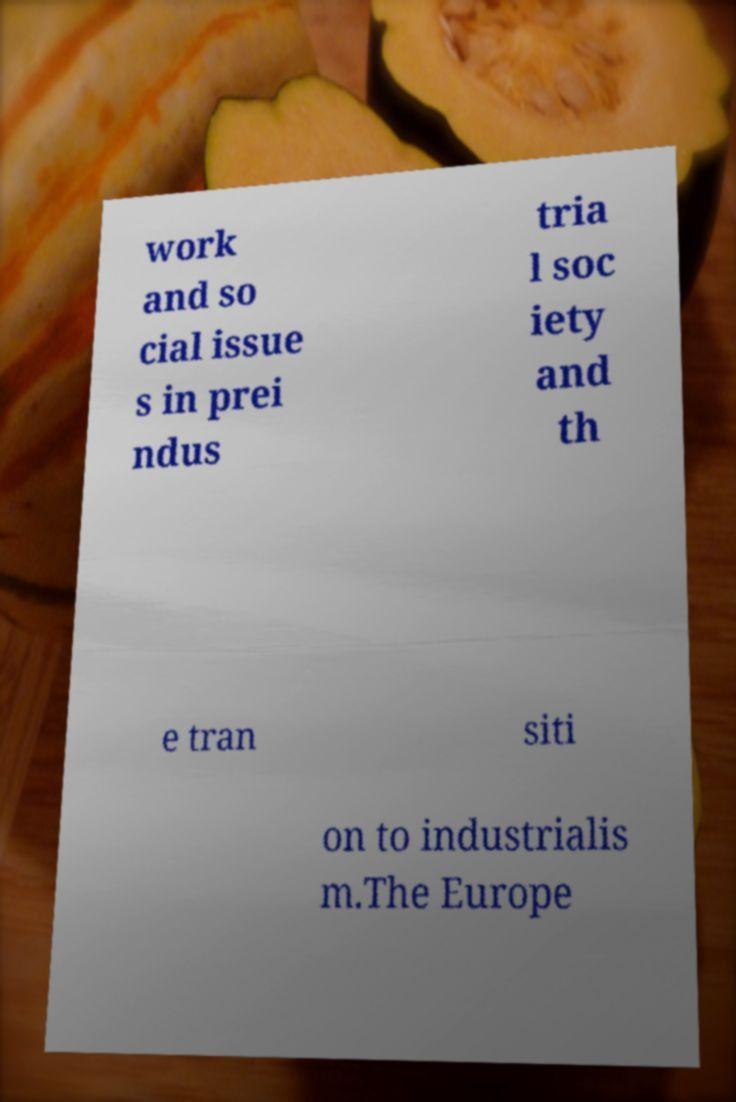Could you extract and type out the text from this image? work and so cial issue s in prei ndus tria l soc iety and th e tran siti on to industrialis m.The Europe 